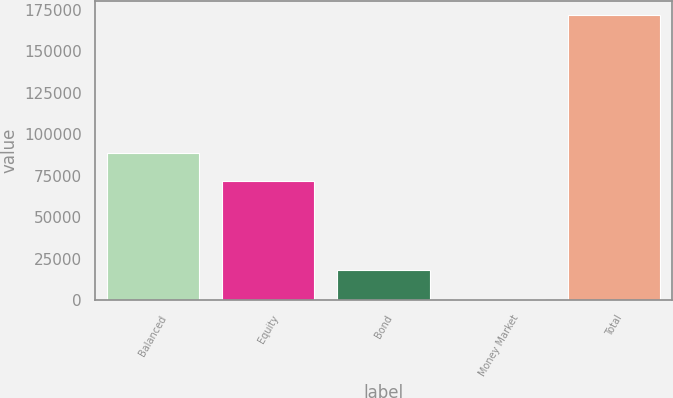Convert chart to OTSL. <chart><loc_0><loc_0><loc_500><loc_500><bar_chart><fcel>Balanced<fcel>Equity<fcel>Bond<fcel>Money Market<fcel>Total<nl><fcel>88824.5<fcel>71742<fcel>18106.5<fcel>1024<fcel>171849<nl></chart> 